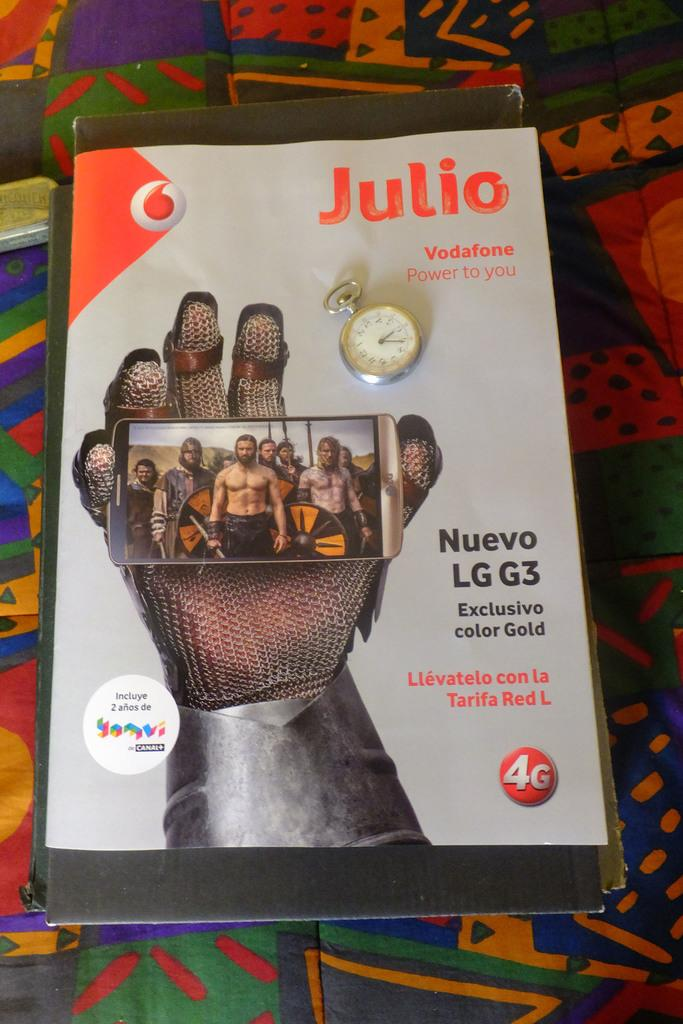Provide a one-sentence caption for the provided image. Magazine cover which has the word "Julio" on the top right. 